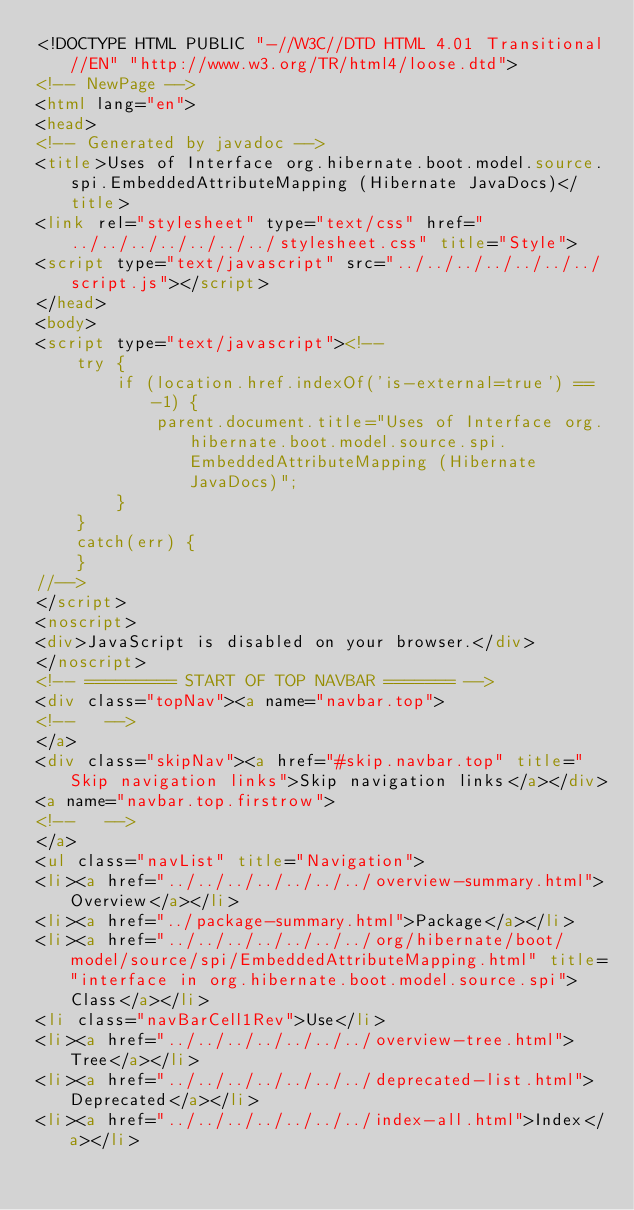Convert code to text. <code><loc_0><loc_0><loc_500><loc_500><_HTML_><!DOCTYPE HTML PUBLIC "-//W3C//DTD HTML 4.01 Transitional//EN" "http://www.w3.org/TR/html4/loose.dtd">
<!-- NewPage -->
<html lang="en">
<head>
<!-- Generated by javadoc -->
<title>Uses of Interface org.hibernate.boot.model.source.spi.EmbeddedAttributeMapping (Hibernate JavaDocs)</title>
<link rel="stylesheet" type="text/css" href="../../../../../../../stylesheet.css" title="Style">
<script type="text/javascript" src="../../../../../../../script.js"></script>
</head>
<body>
<script type="text/javascript"><!--
    try {
        if (location.href.indexOf('is-external=true') == -1) {
            parent.document.title="Uses of Interface org.hibernate.boot.model.source.spi.EmbeddedAttributeMapping (Hibernate JavaDocs)";
        }
    }
    catch(err) {
    }
//-->
</script>
<noscript>
<div>JavaScript is disabled on your browser.</div>
</noscript>
<!-- ========= START OF TOP NAVBAR ======= -->
<div class="topNav"><a name="navbar.top">
<!--   -->
</a>
<div class="skipNav"><a href="#skip.navbar.top" title="Skip navigation links">Skip navigation links</a></div>
<a name="navbar.top.firstrow">
<!--   -->
</a>
<ul class="navList" title="Navigation">
<li><a href="../../../../../../../overview-summary.html">Overview</a></li>
<li><a href="../package-summary.html">Package</a></li>
<li><a href="../../../../../../../org/hibernate/boot/model/source/spi/EmbeddedAttributeMapping.html" title="interface in org.hibernate.boot.model.source.spi">Class</a></li>
<li class="navBarCell1Rev">Use</li>
<li><a href="../../../../../../../overview-tree.html">Tree</a></li>
<li><a href="../../../../../../../deprecated-list.html">Deprecated</a></li>
<li><a href="../../../../../../../index-all.html">Index</a></li></code> 